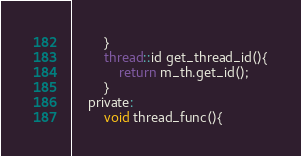Convert code to text. <code><loc_0><loc_0><loc_500><loc_500><_C_>        }
        thread::id get_thread_id(){
            return m_th.get_id();
        }
    private:
        void thread_func(){</code> 